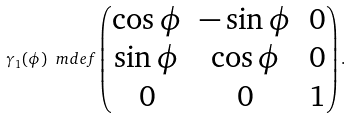Convert formula to latex. <formula><loc_0><loc_0><loc_500><loc_500>\gamma _ { 1 } ( \phi ) \ m d e f \begin{pmatrix} \cos \phi & - \sin \phi & 0 \\ \sin \phi & \cos \phi & 0 \\ 0 & 0 & 1 \end{pmatrix} .</formula> 